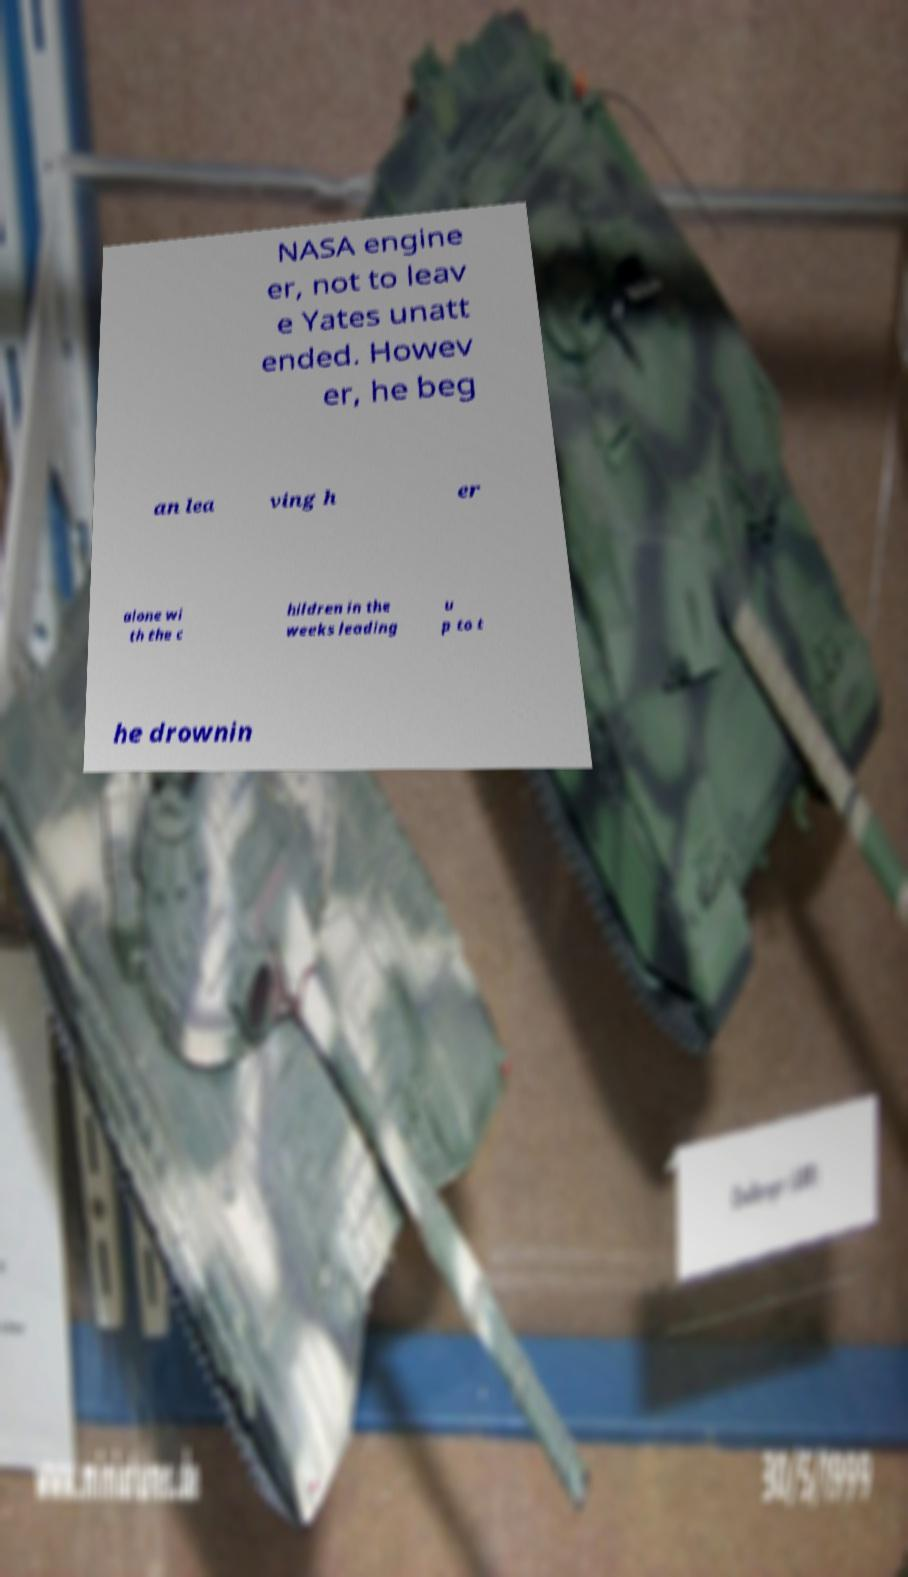Please read and relay the text visible in this image. What does it say? NASA engine er, not to leav e Yates unatt ended. Howev er, he beg an lea ving h er alone wi th the c hildren in the weeks leading u p to t he drownin 